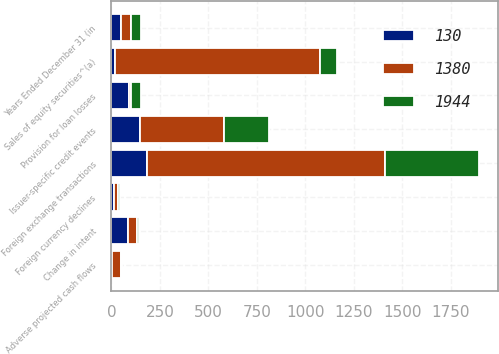Convert chart to OTSL. <chart><loc_0><loc_0><loc_500><loc_500><stacked_bar_chart><ecel><fcel>Years Ended December 31 (in<fcel>Sales of equity securities^(a)<fcel>Change in intent<fcel>Foreign currency declines<fcel>Issuer-specific credit events<fcel>Adverse projected cash flows<fcel>Provision for loan losses<fcel>Foreign exchange transactions<nl><fcel>130<fcel>50<fcel>16<fcel>87<fcel>15<fcel>147<fcel>2<fcel>92<fcel>182<nl><fcel>1944<fcel>50<fcel>88<fcel>9<fcel>11<fcel>234<fcel>4<fcel>50<fcel>489<nl><fcel>1380<fcel>50<fcel>1057<fcel>46<fcel>18<fcel>433<fcel>47<fcel>10<fcel>1226<nl></chart> 